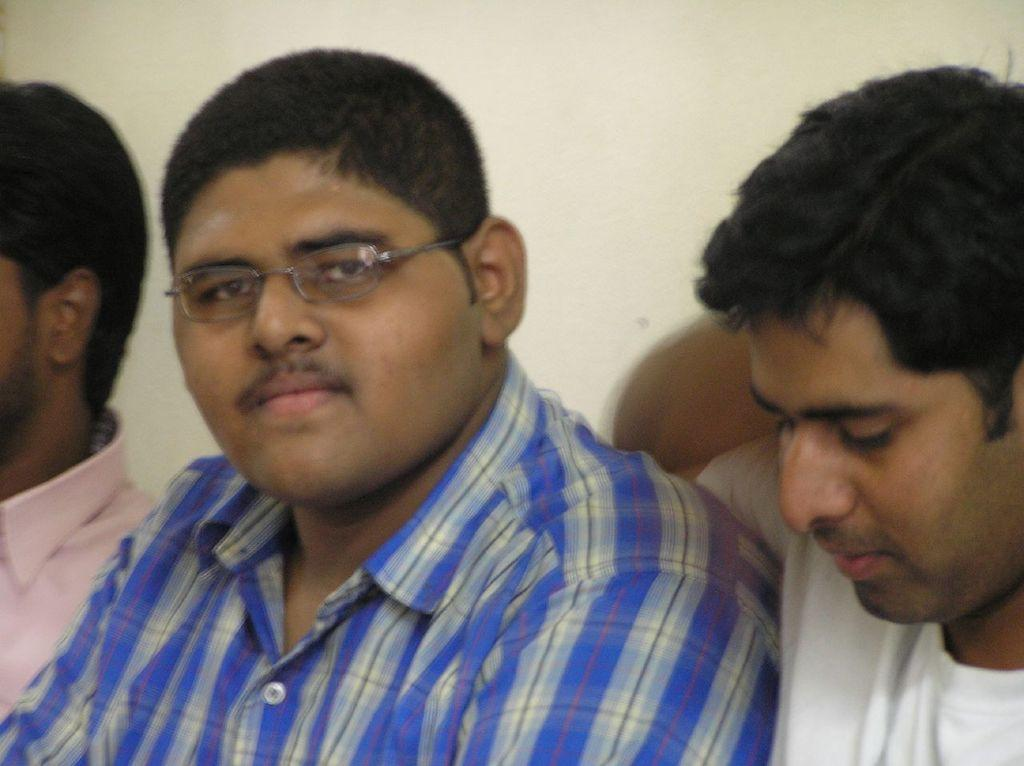How many people are in the image? There are three persons in the image. Can you describe any specific features of one of the persons? One of the persons is wearing spectacles. What is visible in the background of the image? There is a wall in the background of the image. What type of sign can be seen hanging from the wall in the image? There is no sign visible in the image; only the wall is present in the background. 